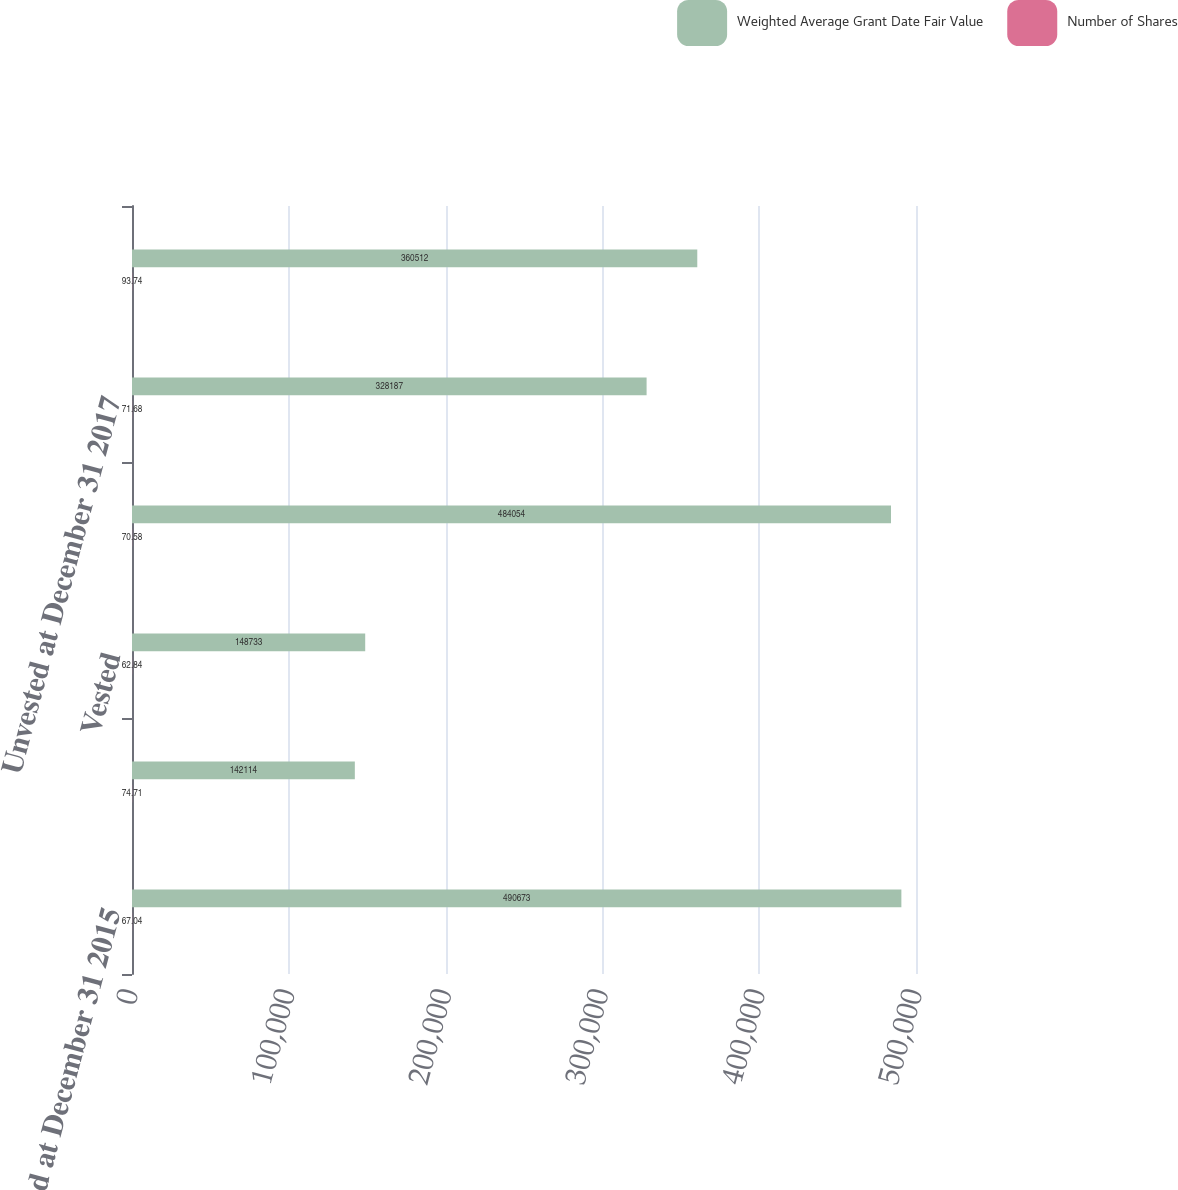Convert chart. <chart><loc_0><loc_0><loc_500><loc_500><stacked_bar_chart><ecel><fcel>Unvested at December 31 2015<fcel>Granted<fcel>Vested<fcel>Unvested at December 31 2016<fcel>Unvested at December 31 2017<fcel>Unvested at December 31 2018<nl><fcel>Weighted Average Grant Date Fair Value<fcel>490673<fcel>142114<fcel>148733<fcel>484054<fcel>328187<fcel>360512<nl><fcel>Number of Shares<fcel>67.04<fcel>74.71<fcel>62.84<fcel>70.58<fcel>71.68<fcel>93.74<nl></chart> 